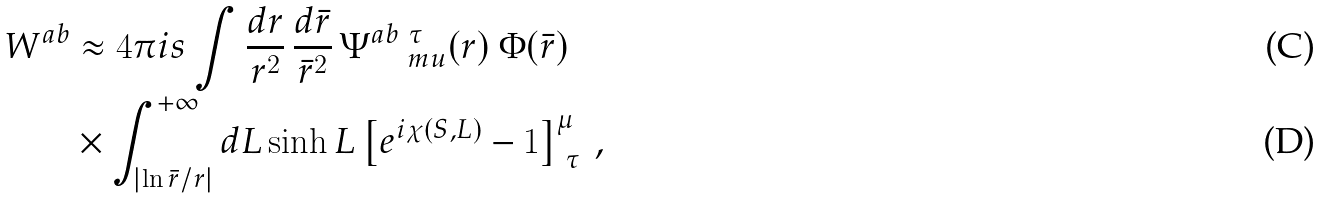<formula> <loc_0><loc_0><loc_500><loc_500>W ^ { a b } & \approx 4 \pi i s \int \frac { d r } { r ^ { 2 } } \, \frac { d \bar { r } } { \bar { r } ^ { 2 } } \, \Psi ^ { a b \ \tau } _ { \quad m u } ( r ) \ \Phi ( \bar { r } ) \\ & \times \int _ { \left | \ln \bar { r } / r \right | } ^ { + \infty } d L \sinh L \left [ e ^ { i \chi ( S , L ) } - 1 \right ] ^ { \mu } _ { \ \tau } \, ,</formula> 